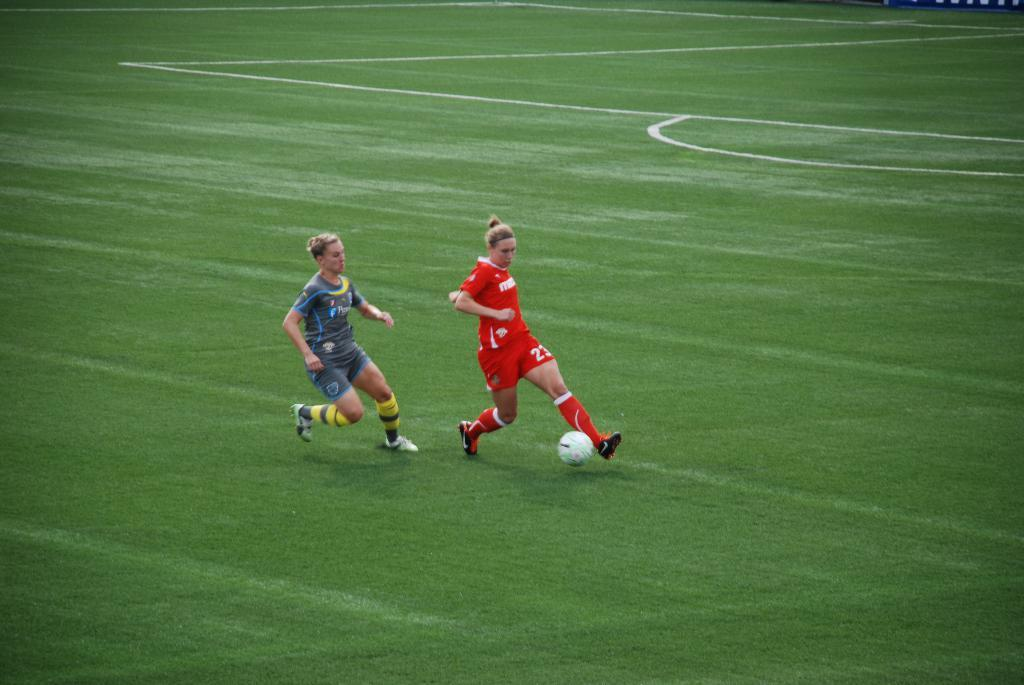Provide a one-sentence caption for the provided image. Number 23 on the red team has the ball is making her way to the goal. 